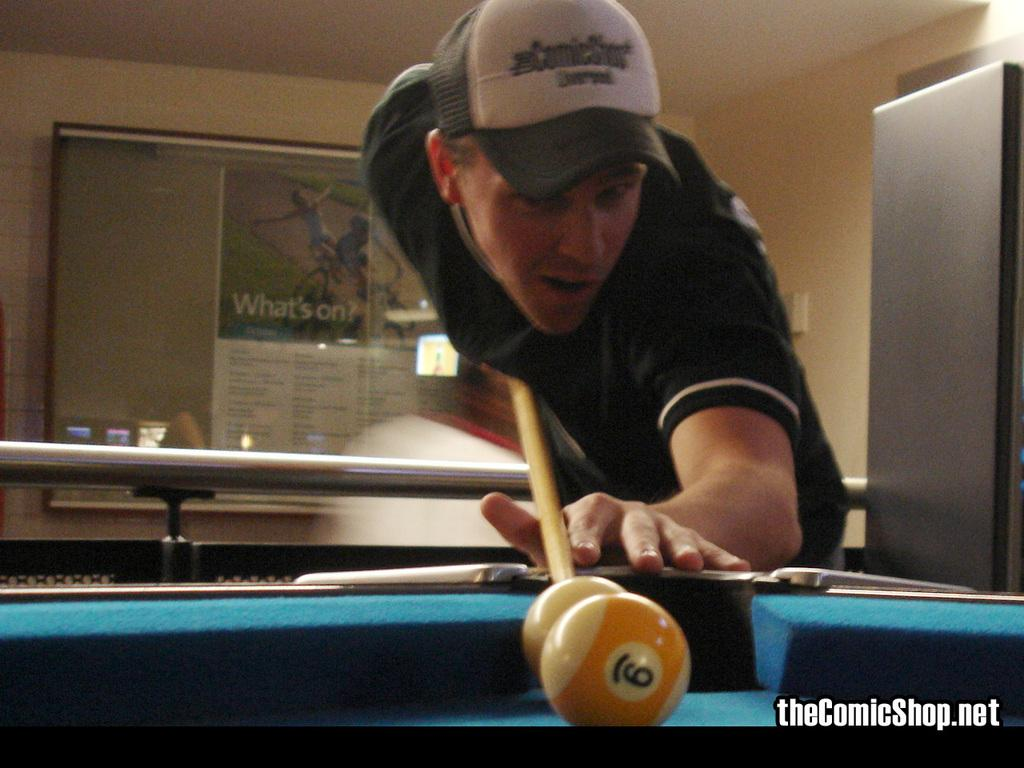What is the person in the image doing? The person is playing table tennis. What object is the person holding in the image? The person is holding a stick, likely a table tennis paddle. What can be seen in the background of the image? There is a wall and a board in the background of the image. What part of the room is visible in the image? The ceiling is visible in the image. What type of treatment is the person receiving for their table tennis experience in the image? There is no indication in the image that the person is receiving any treatment for their table tennis experience. 